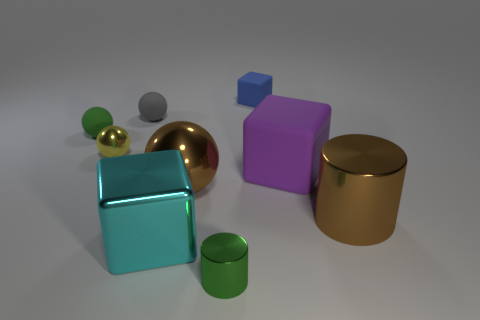The brown metallic object in front of the sphere that is right of the tiny sphere behind the green rubber ball is what shape?
Provide a succinct answer. Cylinder. Is the shape of the yellow thing the same as the tiny shiny object that is to the right of the gray thing?
Give a very brief answer. No. How many small things are yellow shiny objects or green matte spheres?
Make the answer very short. 2. Are there any cyan objects that have the same size as the green cylinder?
Ensure brevity in your answer.  No. There is a small metallic thing that is to the left of the tiny green thing that is in front of the matte cube in front of the gray thing; what color is it?
Offer a very short reply. Yellow. Do the big cyan thing and the small thing in front of the tiny shiny ball have the same material?
Provide a succinct answer. Yes. There is a gray thing that is the same shape as the green rubber object; what is its size?
Give a very brief answer. Small. Are there the same number of large matte objects to the left of the green metallic object and cyan shiny things that are on the right side of the big brown cylinder?
Your response must be concise. Yes. How many other objects are the same material as the yellow ball?
Provide a succinct answer. 4. Is the number of big matte objects behind the big brown metallic sphere the same as the number of small gray matte cylinders?
Your answer should be very brief. No. 